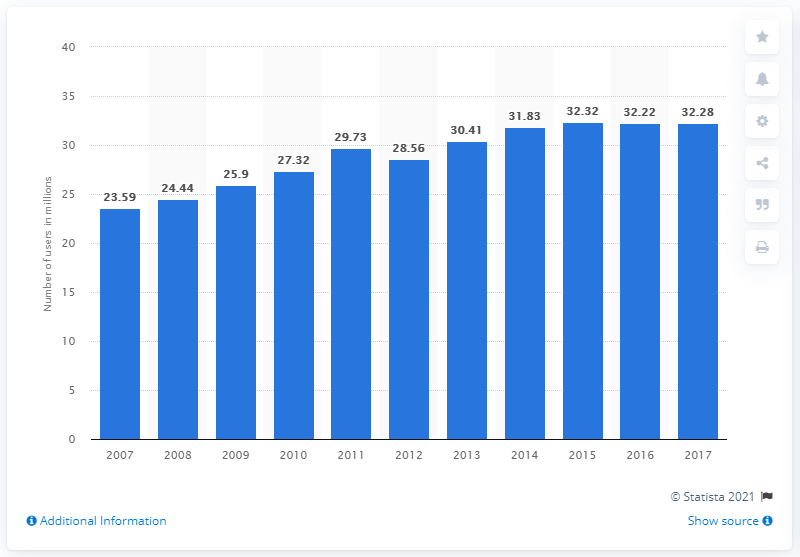Outline some significant characteristics in this image. In 2017, 32,280 people used an elliptical motion trainer. 